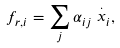Convert formula to latex. <formula><loc_0><loc_0><loc_500><loc_500>f _ { r , i } = \sum _ { j } \alpha _ { i j } \stackrel { . } { x } _ { i } ,</formula> 